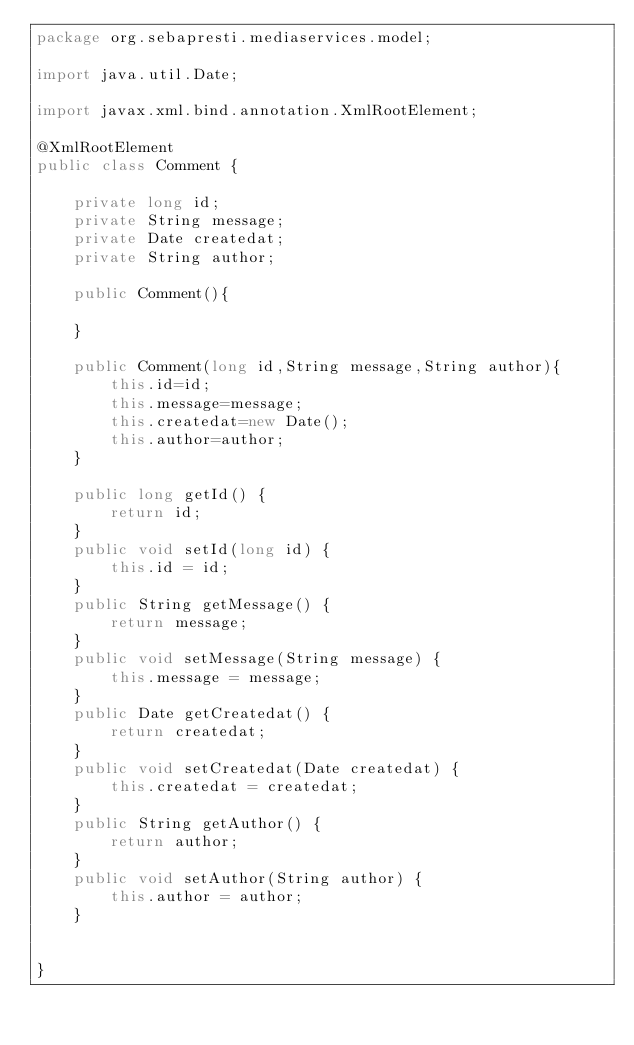Convert code to text. <code><loc_0><loc_0><loc_500><loc_500><_Java_>package org.sebapresti.mediaservices.model;

import java.util.Date;

import javax.xml.bind.annotation.XmlRootElement;

@XmlRootElement
public class Comment {

	private long id;
	private String message;
	private Date createdat;
	private String author;
	
	public Comment(){
		
	}
	
	public Comment(long id,String message,String author){
		this.id=id;
		this.message=message;
		this.createdat=new Date();
		this.author=author;
	}
	
	public long getId() {
		return id;
	}
	public void setId(long id) {
		this.id = id;
	}
	public String getMessage() {
		return message;
	}
	public void setMessage(String message) {
		this.message = message;
	}
	public Date getCreatedat() {
		return createdat;
	}
	public void setCreatedat(Date createdat) {
		this.createdat = createdat;
	}
	public String getAuthor() {
		return author;
	}
	public void setAuthor(String author) {
		this.author = author;
	}
	
	
}
</code> 